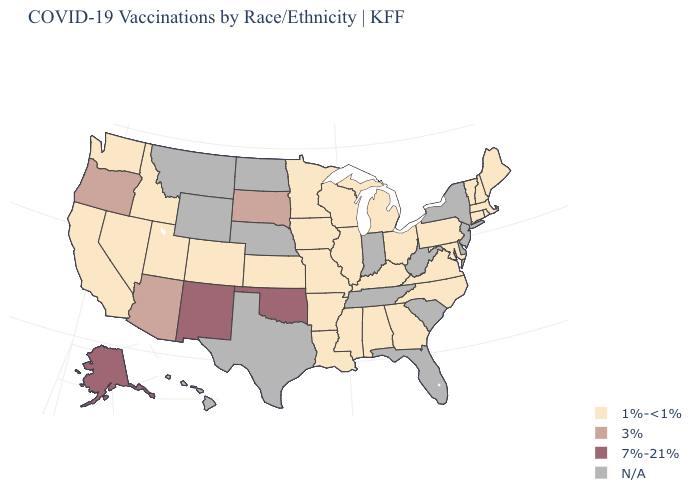Is the legend a continuous bar?
Answer briefly. No. What is the value of Minnesota?
Quick response, please. 1%-<1%. What is the highest value in the MidWest ?
Concise answer only. 3%. Name the states that have a value in the range 7%-21%?
Be succinct. Alaska, New Mexico, Oklahoma. Name the states that have a value in the range 1%-<1%?
Give a very brief answer. Alabama, Arkansas, California, Colorado, Connecticut, Georgia, Idaho, Illinois, Iowa, Kansas, Kentucky, Louisiana, Maine, Maryland, Massachusetts, Michigan, Minnesota, Mississippi, Missouri, Nevada, New Hampshire, North Carolina, Ohio, Pennsylvania, Rhode Island, Utah, Vermont, Virginia, Washington, Wisconsin. What is the lowest value in the USA?
Be succinct. 1%-<1%. What is the lowest value in the USA?
Quick response, please. 1%-<1%. What is the highest value in the South ?
Answer briefly. 7%-21%. What is the value of Wisconsin?
Be succinct. 1%-<1%. Name the states that have a value in the range 1%-<1%?
Concise answer only. Alabama, Arkansas, California, Colorado, Connecticut, Georgia, Idaho, Illinois, Iowa, Kansas, Kentucky, Louisiana, Maine, Maryland, Massachusetts, Michigan, Minnesota, Mississippi, Missouri, Nevada, New Hampshire, North Carolina, Ohio, Pennsylvania, Rhode Island, Utah, Vermont, Virginia, Washington, Wisconsin. Does New Mexico have the highest value in the USA?
Give a very brief answer. Yes. Name the states that have a value in the range 7%-21%?
Write a very short answer. Alaska, New Mexico, Oklahoma. Among the states that border Louisiana , which have the lowest value?
Concise answer only. Arkansas, Mississippi. Does the map have missing data?
Answer briefly. Yes. 